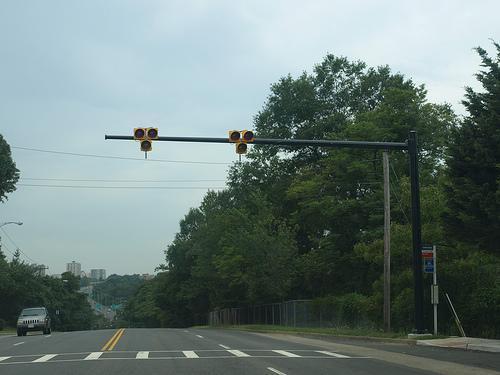How many street lights are there?
Give a very brief answer. 2. How many lamps are on each street light?
Give a very brief answer. 3. 